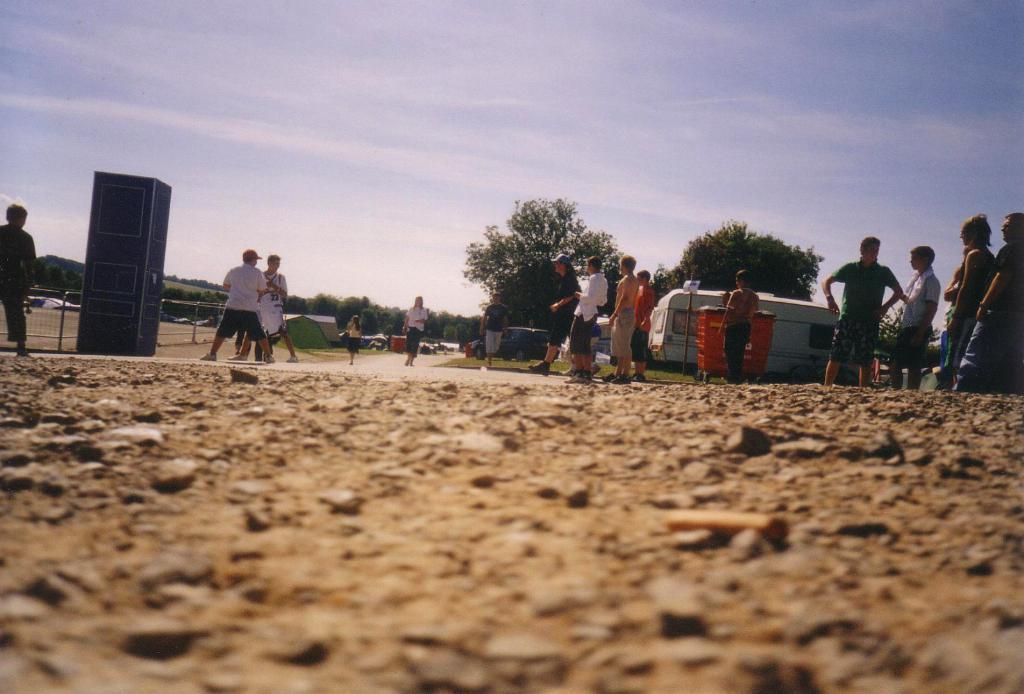In one or two sentences, can you explain what this image depicts? In this image we can see group of persons standing on the ground. In the background we can see vehicle, dustbin, trees, tents, sky and clouds. At the bottom we can see stones and ground. 